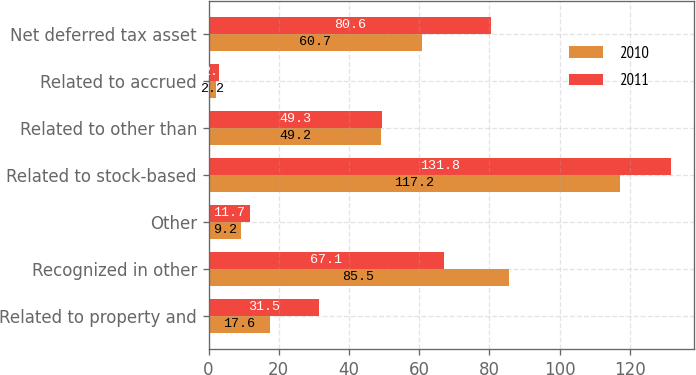Convert chart. <chart><loc_0><loc_0><loc_500><loc_500><stacked_bar_chart><ecel><fcel>Related to property and<fcel>Recognized in other<fcel>Other<fcel>Related to stock-based<fcel>Related to other than<fcel>Related to accrued<fcel>Net deferred tax asset<nl><fcel>2010<fcel>17.6<fcel>85.5<fcel>9.2<fcel>117.2<fcel>49.2<fcel>2.2<fcel>60.7<nl><fcel>2011<fcel>31.5<fcel>67.1<fcel>11.7<fcel>131.8<fcel>49.3<fcel>2.9<fcel>80.6<nl></chart> 